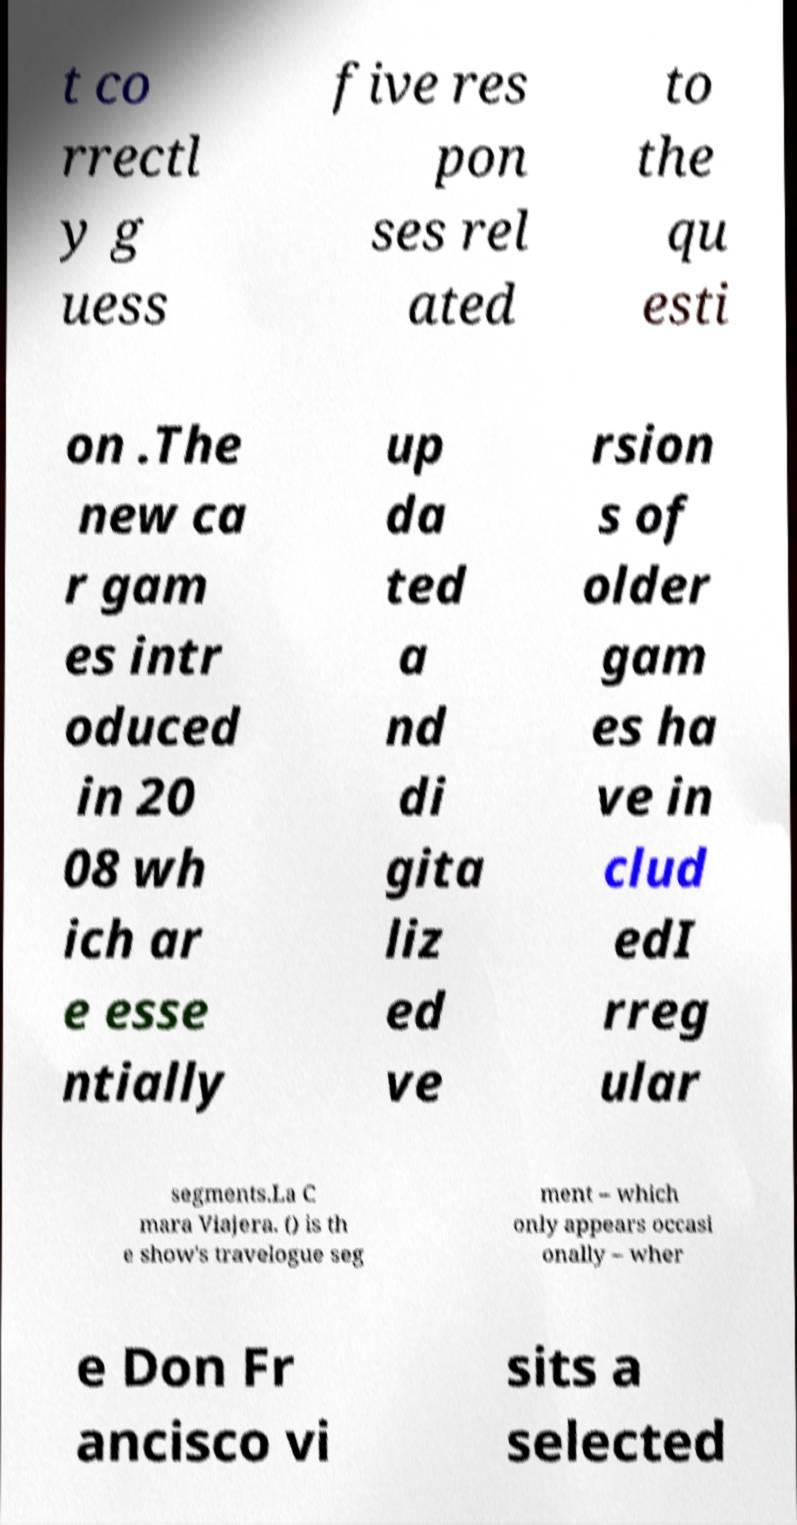Can you read and provide the text displayed in the image?This photo seems to have some interesting text. Can you extract and type it out for me? t co rrectl y g uess five res pon ses rel ated to the qu esti on .The new ca r gam es intr oduced in 20 08 wh ich ar e esse ntially up da ted a nd di gita liz ed ve rsion s of older gam es ha ve in clud edI rreg ular segments.La C mara Viajera. () is th e show's travelogue seg ment – which only appears occasi onally – wher e Don Fr ancisco vi sits a selected 